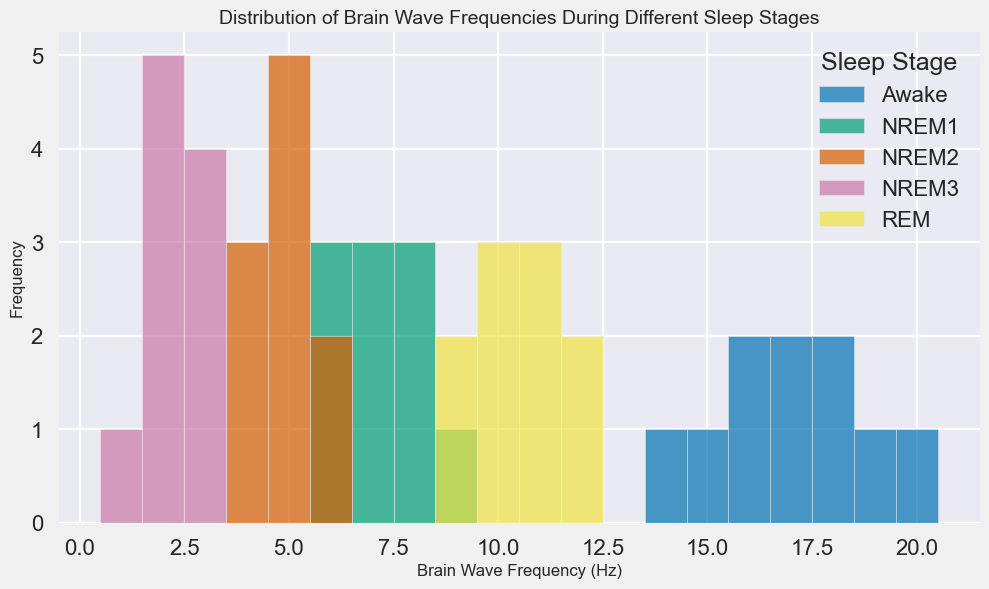What sleep stage shows the widest range of brain wave frequencies? To find this, we look at the span of the histogram bins for each sleep stage. The sleep stage with the largest difference between the highest and lowest frequency values has the widest range. Here, the Awake stage ranges from 14 Hz to 20 Hz, which is a 6 Hz range.
Answer: Awake Which sleep stage has the most concentrated (least varied) brain wave frequencies? To determine this, we observe the concentration of bars for each sleep stage. The NREM3 stage shows the least variation, with frequencies concentrated between 1 Hz and 3 Hz.
Answer: NREM3 How do the median brain wave frequencies of the REM and NREM1 stages compare? For REM, the frequencies range from 9 Hz to 12 Hz. The middle value is 10.5 Hz (average of 10 Hz and 11 Hz since there are an even number of values). For NREM1, the frequency values primarily cluster around 7 Hz and 8 Hz. The median here is 7.5 Hz. Comparing these medians, REM has a higher median frequency.
Answer: REM has a higher median frequency than NREM1 During which sleep stage are the brain wave frequencies most likely to be below 5 Hz? We need to see which stage has the majority of its bars representing frequencies below 5 Hz. NREM2 and NREM3 stages show frequencies primarily in the 1-5 Hz range. NREM3 has a higher concentration near the lower end.
Answer: NREM3 What is the most common brain wave frequency during the NREM1 stage? By looking at the height of the bars in the histogram for the NREM1 stage, the highest bar signifies the most common frequency. The highest bar occurs at a frequency just below 8 Hz.
Answer: 7 Hz Compare the spread of brain wave frequencies for Awake and REM stages. Which is more spread out? By observing the range of frequencies, the Awake stage shows a distribution from about 14 Hz to 20 Hz, whereas REM ranges from 9 Hz to 12 Hz. Awake thus has a wider spread.
Answer: Awake Which sleep stage has the tallest bar in the histogram, and what does it represent? The tallest bar in the histogram represents the sleep stage with the highest single frequency count. Upon visual inspection, NREM2 has the tallest bar, representing the 5 Hz frequency.
Answer: NREM2, 5 Hz Do any sleep stages have overlapping brain wave frequencies? If so, which ones? By looking for common frequency bins between sleep stages, we see that NREM1 and NREM2 overlap around 6 Hz, and REM slightly overlaps NREM1 around 9 Hz.
Answer: NREM1 and NREM2; NREM1 and REM How many sleep stages have their peak frequency (highest bar) above 15 Hz? Looking at the histogram, we see that only the Awake stage has its peak even above 15 Hz, reaching up to 20 Hz. All other stages peak below this value.
Answer: 1 